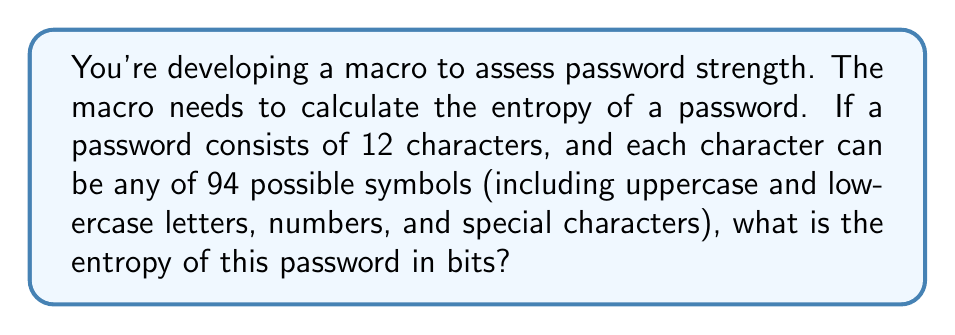Can you solve this math problem? To calculate the entropy of a password, we use the formula:

$$ E = L \log_2(R) $$

Where:
$E$ = entropy in bits
$L$ = length of the password
$R$ = size of the character set (pool of possible characters)

Given:
$L = 12$ (password length)
$R = 94$ (possible symbols)

Let's substitute these values into the formula:

$$ E = 12 \log_2(94) $$

Now, we need to calculate $\log_2(94)$. We can use the change of base formula:

$$ \log_2(94) = \frac{\log(94)}{\log(2)} $$

Using a calculator or programming function:

$$ \log_2(94) \approx 6.5546 $$

Now, we can complete the calculation:

$$ E = 12 \times 6.5546 $$
$$ E \approx 78.6552 \text{ bits} $$

Rounding to two decimal places:

$$ E \approx 78.66 \text{ bits} $$

This result represents the theoretical entropy of the password, which is a measure of its randomness and, consequently, its strength against brute-force attacks.
Answer: 78.66 bits 